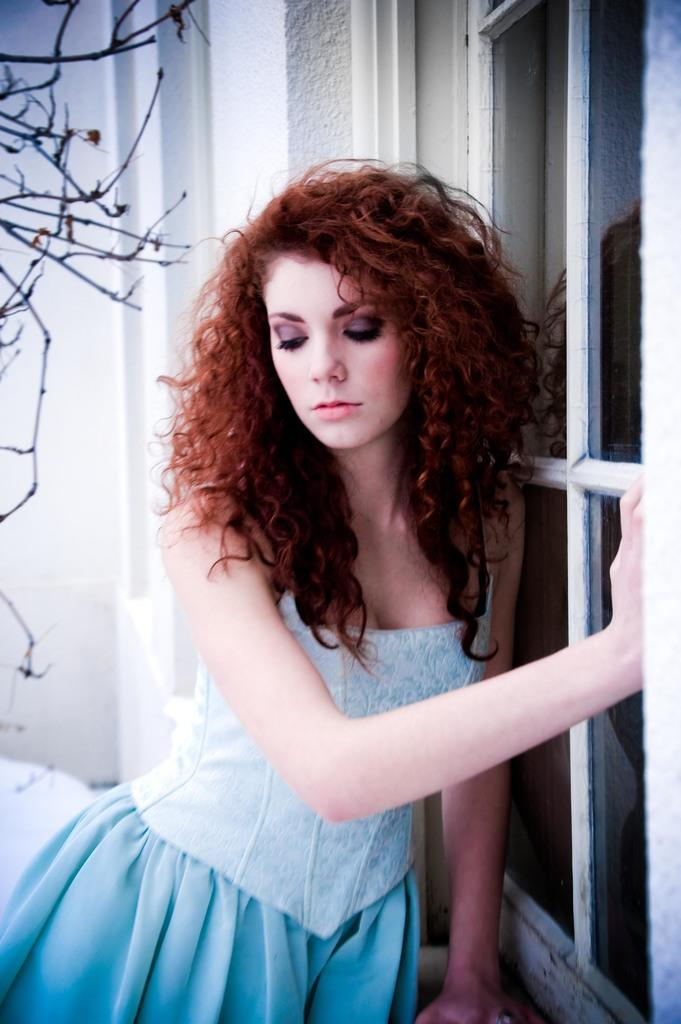What is the woman in the image wearing? The woman is wearing a blue dress. Can you describe the woman's surroundings in the image? There is a window with a glass door and tree stems visible at the left side of the image. There is also a wall in the image. What is the color of the dress the woman is wearing? The woman is wearing a blue dress. What type of railway can be seen in the image? There is no railway present in the image. How does the woman's head appear in the image? The image does not show the woman's head, only her body and the surroundings. 